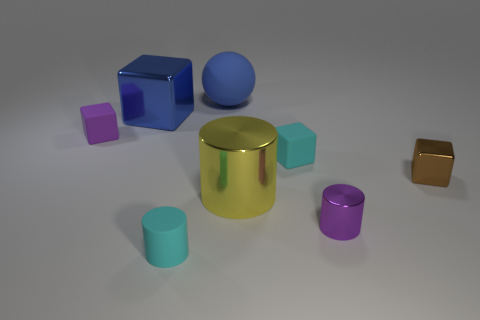Subtract all tiny brown cubes. How many cubes are left? 3 Add 1 brown shiny cubes. How many objects exist? 9 Subtract all cyan cubes. How many cubes are left? 3 Add 8 purple things. How many purple things are left? 10 Add 1 big metal cubes. How many big metal cubes exist? 2 Subtract 0 brown balls. How many objects are left? 8 Subtract all spheres. How many objects are left? 7 Subtract 1 spheres. How many spheres are left? 0 Subtract all yellow balls. Subtract all purple cubes. How many balls are left? 1 Subtract all purple spheres. How many cyan cylinders are left? 1 